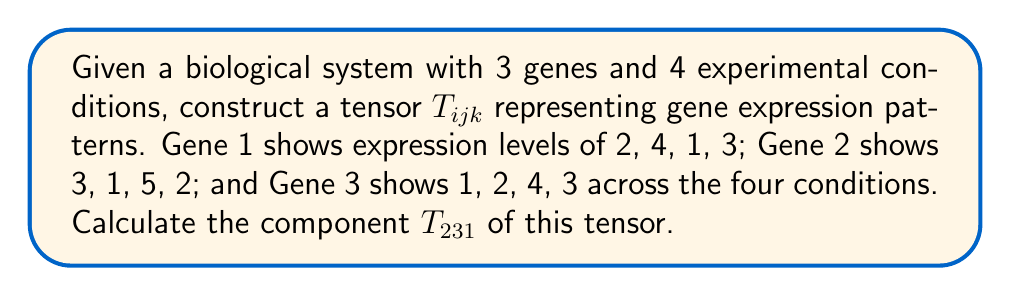Help me with this question. 1. First, we need to understand the structure of the tensor:
   - $i$ represents the gene (1, 2, or 3)
   - $j$ represents the experimental condition (1, 2, 3, or 4)
   - $k$ represents the expression level for each gene-condition pair

2. We can represent the data as a 3D tensor:

   $$T = \begin{bmatrix}
   [2 & 4 & 1 & 3] \\
   [3 & 1 & 5 & 2] \\
   [1 & 2 & 4 & 3]
   \end{bmatrix}$$

3. The component $T_{231}$ refers to:
   - Gene 2 ($i = 2$)
   - Experimental condition 3 ($j = 3$)
   - The expression level ($k = 1$, as we're looking for a single value)

4. Looking at the tensor, we find that for Gene 2 (second row) and experimental condition 3 (third column), the expression level is 5.

Therefore, $T_{231} = 5$.
Answer: $T_{231} = 5$ 